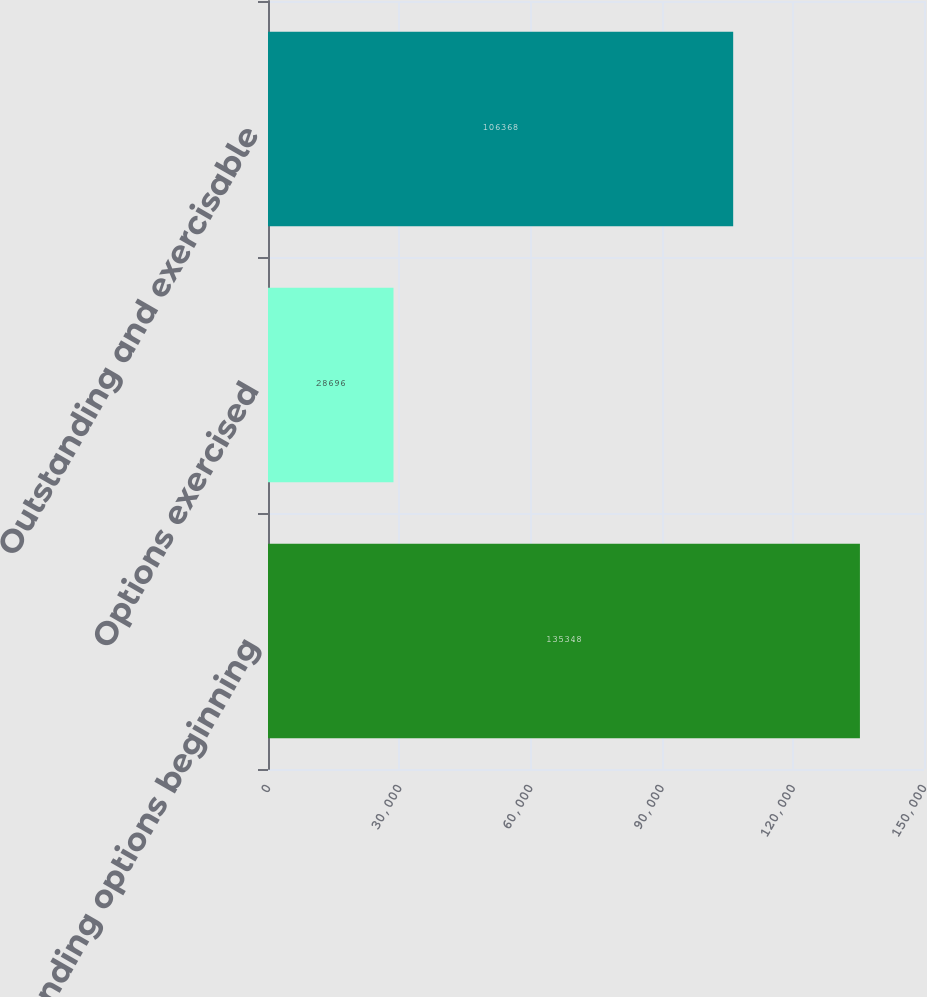Convert chart to OTSL. <chart><loc_0><loc_0><loc_500><loc_500><bar_chart><fcel>Outstanding options beginning<fcel>Options exercised<fcel>Outstanding and exercisable<nl><fcel>135348<fcel>28696<fcel>106368<nl></chart> 